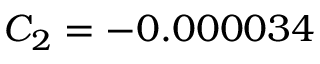Convert formula to latex. <formula><loc_0><loc_0><loc_500><loc_500>C _ { 2 } = - 0 . 0 0 0 0 3 4</formula> 